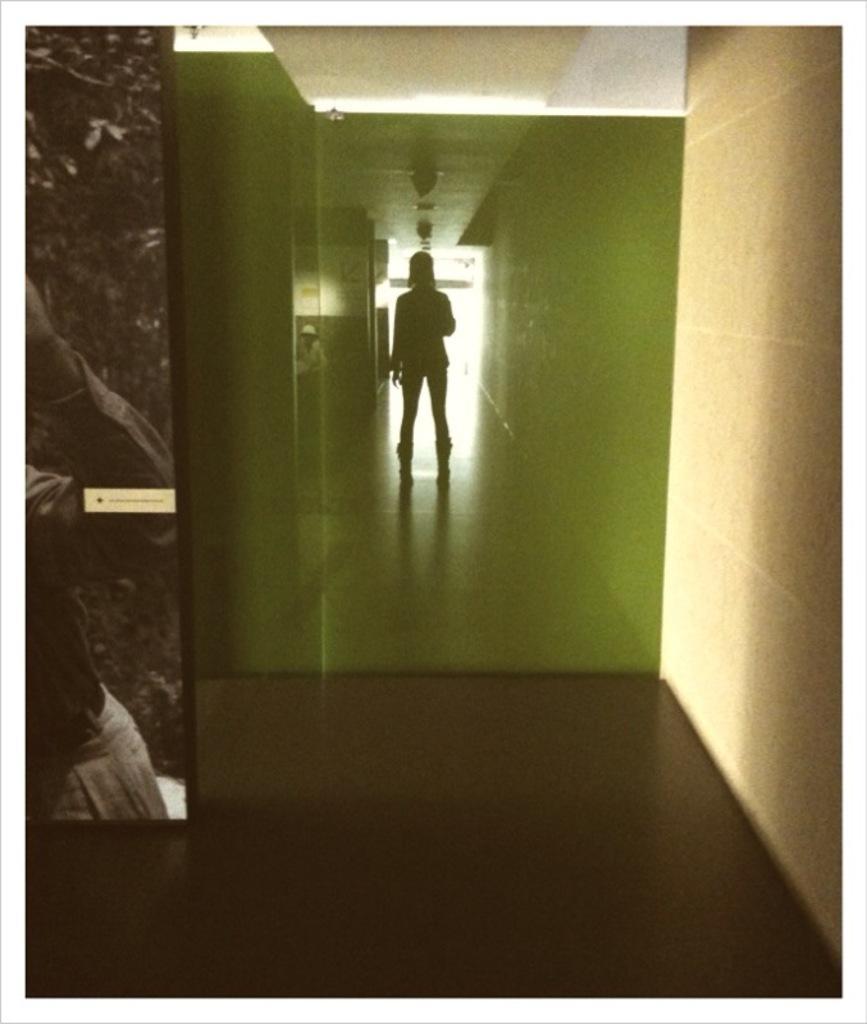Can you describe this image briefly? This picture is clicked inside. On the left we can see the picture of a person. In the center there is a person seems to be standing on the ground. On the right there is a wall. At the top we can see the roof. 